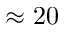Convert formula to latex. <formula><loc_0><loc_0><loc_500><loc_500>\approx 2 0</formula> 